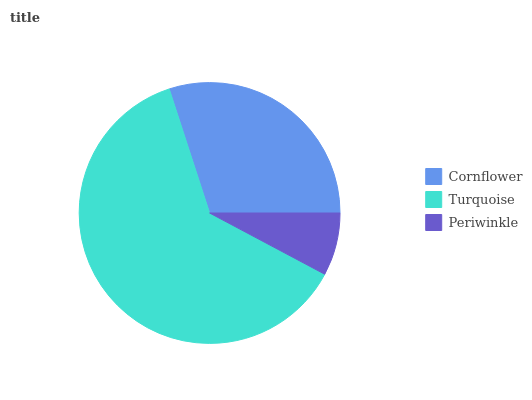Is Periwinkle the minimum?
Answer yes or no. Yes. Is Turquoise the maximum?
Answer yes or no. Yes. Is Turquoise the minimum?
Answer yes or no. No. Is Periwinkle the maximum?
Answer yes or no. No. Is Turquoise greater than Periwinkle?
Answer yes or no. Yes. Is Periwinkle less than Turquoise?
Answer yes or no. Yes. Is Periwinkle greater than Turquoise?
Answer yes or no. No. Is Turquoise less than Periwinkle?
Answer yes or no. No. Is Cornflower the high median?
Answer yes or no. Yes. Is Cornflower the low median?
Answer yes or no. Yes. Is Periwinkle the high median?
Answer yes or no. No. Is Turquoise the low median?
Answer yes or no. No. 